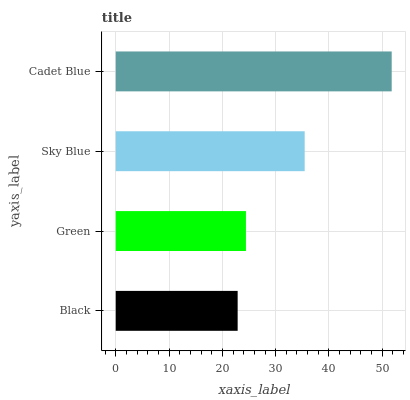Is Black the minimum?
Answer yes or no. Yes. Is Cadet Blue the maximum?
Answer yes or no. Yes. Is Green the minimum?
Answer yes or no. No. Is Green the maximum?
Answer yes or no. No. Is Green greater than Black?
Answer yes or no. Yes. Is Black less than Green?
Answer yes or no. Yes. Is Black greater than Green?
Answer yes or no. No. Is Green less than Black?
Answer yes or no. No. Is Sky Blue the high median?
Answer yes or no. Yes. Is Green the low median?
Answer yes or no. Yes. Is Black the high median?
Answer yes or no. No. Is Sky Blue the low median?
Answer yes or no. No. 